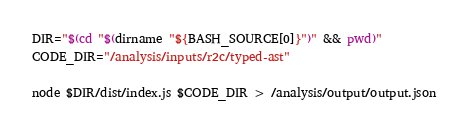Convert code to text. <code><loc_0><loc_0><loc_500><loc_500><_Bash_>DIR="$(cd "$(dirname "${BASH_SOURCE[0]}")" && pwd)"
CODE_DIR="/analysis/inputs/r2c/typed-ast"

node $DIR/dist/index.js $CODE_DIR > /analysis/output/output.json
</code> 